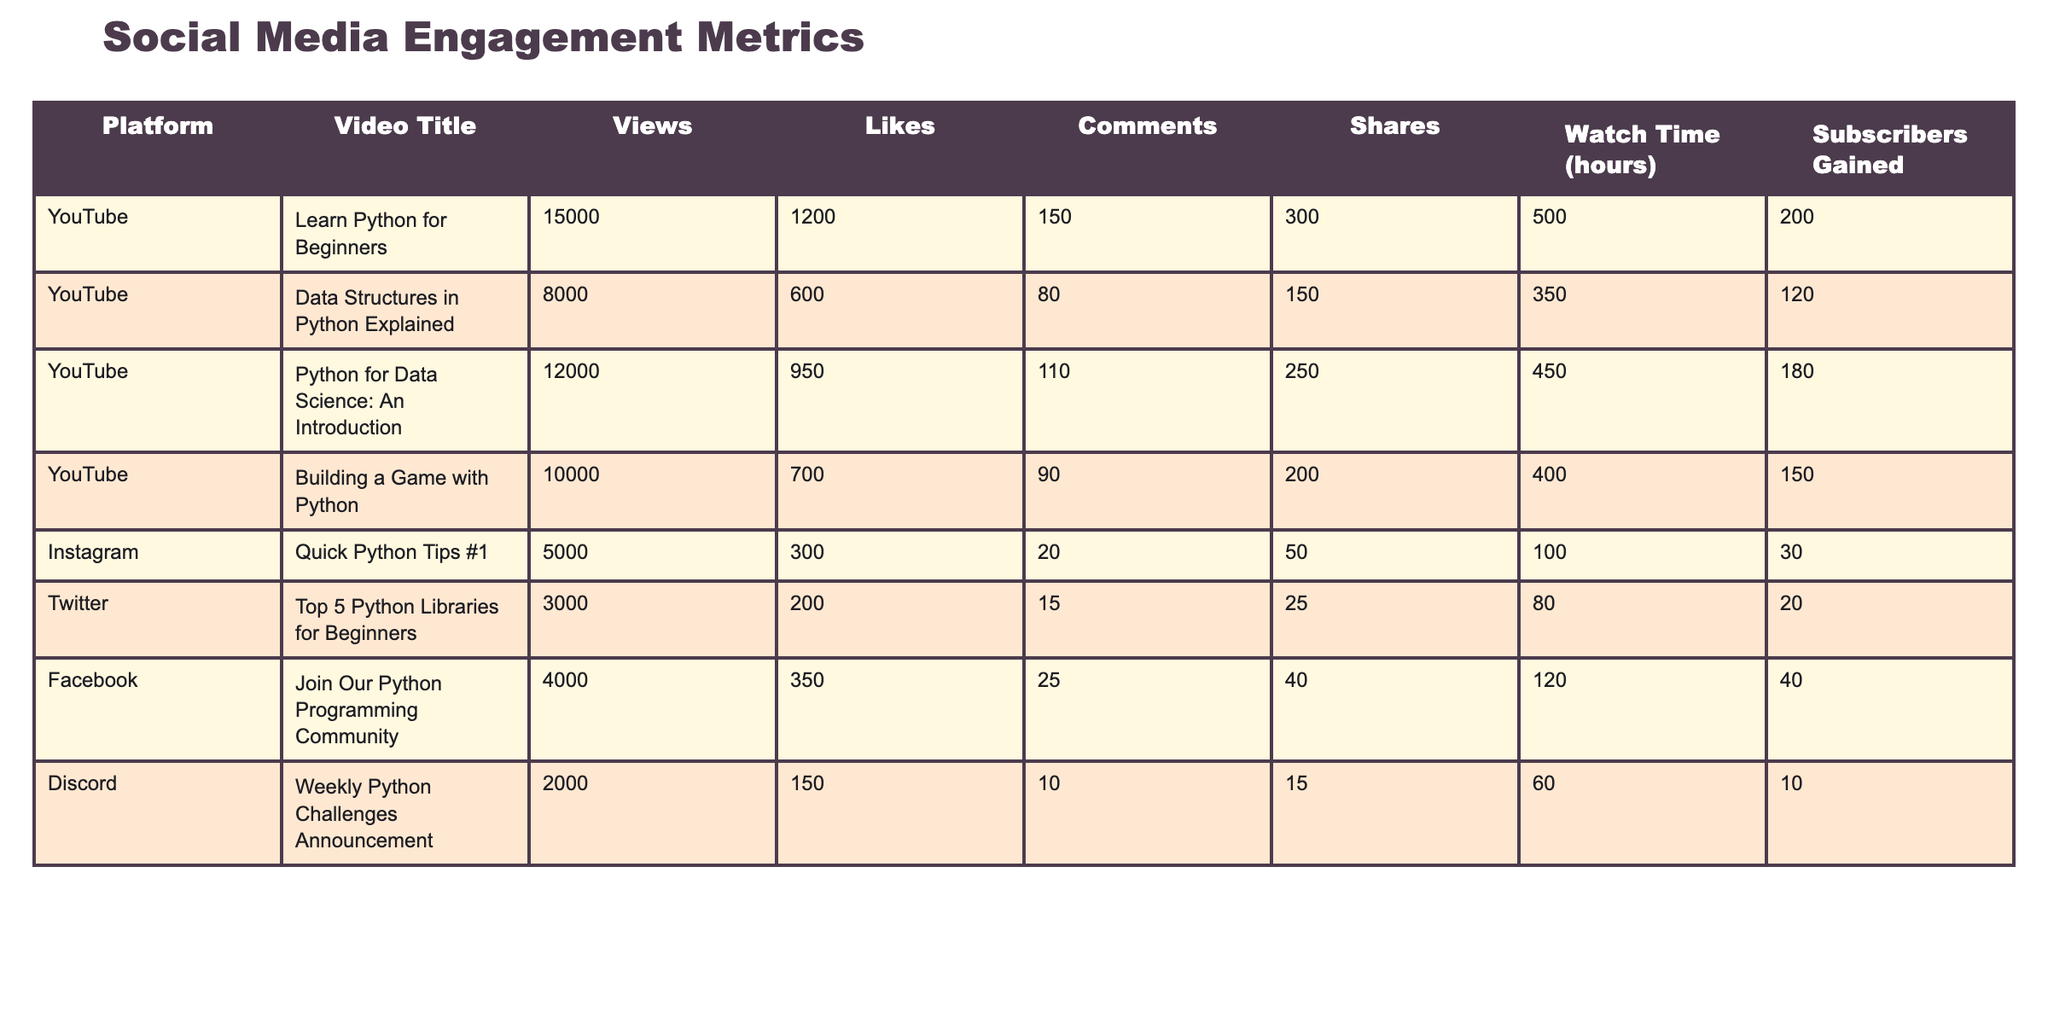What platform had the highest number of views? Looking at the "Views" column, the video with the highest views is "Learn Python for Beginners" with 15000 views, which belongs to the YouTube platform.
Answer: YouTube What is the sum of likes across all videos on Instagram? The likes for Instagram videos from the table are 300 for "Quick Python Tips #1". There are no other Instagram videos listed, so the sum is simply 300.
Answer: 300 Is it true that the video "Building a Game with Python" has more comments than "Data Structures in Python Explained"? Comparing the comments, "Building a Game with Python" has 90 comments, while "Data Structures in Python Explained" has 80 comments. Since 90 is greater than 80, the statement is true.
Answer: Yes What is the average watch time in hours for all videos listed on Twitter and Facebook? For Twitter, the watch time is 80 hours, and for Facebook, it is 120 hours. To find the average, we sum these: 80 + 120 = 200, and then divide by 2, resulting in 200 / 2 = 100 hours.
Answer: 100 What is the total number of subscribers gained from the "Python for Data Science: An Introduction" and "Building a Game with Python" videos? The subscribers gained from "Python for Data Science: An Introduction" is 180 and from "Building a Game with Python" is 150. Adding them together gives us 180 + 150 = 330 subscribers gained.
Answer: 330 Which video had the least number of shares, and what was the count? Looking through the "Shares" column, "Weekly Python Challenges Announcement" had the least shares with a count of 15.
Answer: Weekly Python Challenges Announcement, 15 What percentage of total views did the "Data Structures in Python Explained" video receive relative to the total views of all videos? The total views across all videos is 15000 + 8000 + 12000 + 10000 + 5000 + 3000 + 4000 + 2000 = 60000. The views for "Data Structures in Python Explained" is 8000. To find the percentage, we can calculate (8000 / 60000) * 100, which equals approximately 13.33%.
Answer: 13.33% Which platform had the most videos listed in the table? Counting the videos, YouTube has 4 videos listed, while Instagram, Twitter, Facebook, and Discord have 1 video each. Since 4 is greater than all others, YouTube has the most videos listed.
Answer: YouTube 